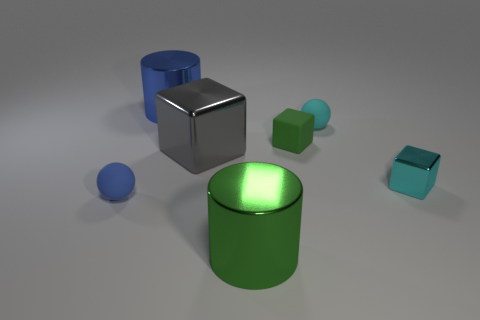There is a small cyan thing that is the same shape as the large gray thing; what material is it? metal 